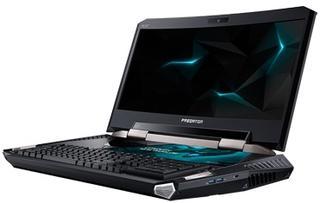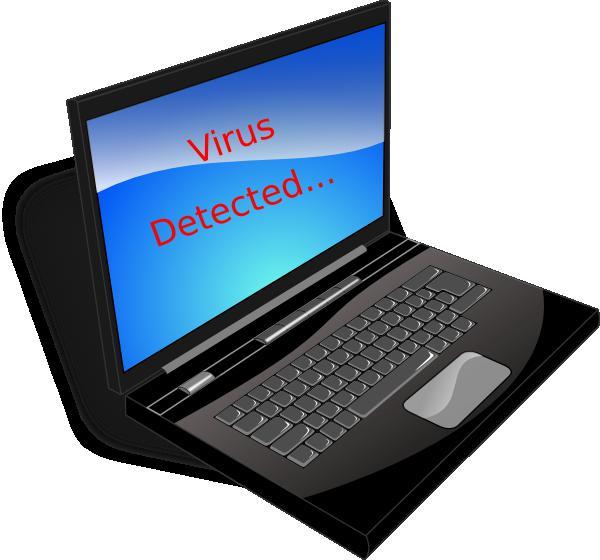The first image is the image on the left, the second image is the image on the right. Evaluate the accuracy of this statement regarding the images: "Each image shows one opened laptop displayed turned at an angle.". Is it true? Answer yes or no. Yes. The first image is the image on the left, the second image is the image on the right. For the images displayed, is the sentence "Apps are shown on exactly one of the laptops." factually correct? Answer yes or no. No. 